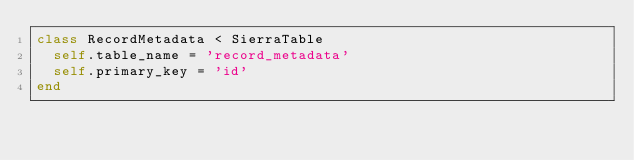<code> <loc_0><loc_0><loc_500><loc_500><_Ruby_>class RecordMetadata < SierraTable
  self.table_name = 'record_metadata'
  self.primary_key = 'id'
end
</code> 